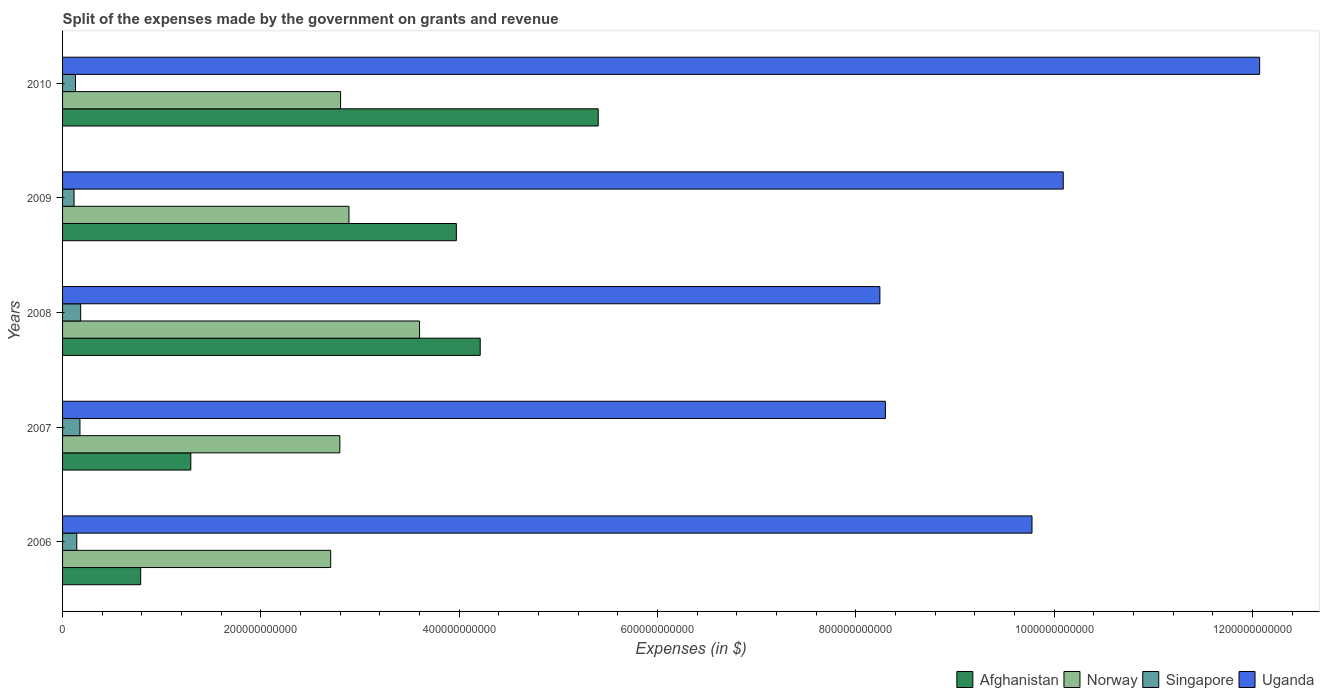How many groups of bars are there?
Offer a very short reply. 5. Are the number of bars per tick equal to the number of legend labels?
Offer a terse response. Yes. How many bars are there on the 5th tick from the top?
Your response must be concise. 4. How many bars are there on the 3rd tick from the bottom?
Offer a terse response. 4. In how many cases, is the number of bars for a given year not equal to the number of legend labels?
Your answer should be compact. 0. What is the expenses made by the government on grants and revenue in Singapore in 2008?
Your answer should be compact. 1.82e+1. Across all years, what is the maximum expenses made by the government on grants and revenue in Norway?
Offer a very short reply. 3.60e+11. Across all years, what is the minimum expenses made by the government on grants and revenue in Norway?
Keep it short and to the point. 2.70e+11. In which year was the expenses made by the government on grants and revenue in Norway minimum?
Provide a succinct answer. 2006. What is the total expenses made by the government on grants and revenue in Norway in the graph?
Provide a succinct answer. 1.48e+12. What is the difference between the expenses made by the government on grants and revenue in Singapore in 2006 and that in 2010?
Make the answer very short. 1.27e+09. What is the difference between the expenses made by the government on grants and revenue in Afghanistan in 2010 and the expenses made by the government on grants and revenue in Uganda in 2006?
Ensure brevity in your answer.  -4.37e+11. What is the average expenses made by the government on grants and revenue in Norway per year?
Offer a terse response. 2.96e+11. In the year 2009, what is the difference between the expenses made by the government on grants and revenue in Uganda and expenses made by the government on grants and revenue in Singapore?
Your answer should be very brief. 9.98e+11. In how many years, is the expenses made by the government on grants and revenue in Singapore greater than 1080000000000 $?
Offer a terse response. 0. What is the ratio of the expenses made by the government on grants and revenue in Singapore in 2006 to that in 2008?
Offer a very short reply. 0.79. Is the expenses made by the government on grants and revenue in Singapore in 2008 less than that in 2010?
Your response must be concise. No. What is the difference between the highest and the second highest expenses made by the government on grants and revenue in Afghanistan?
Offer a very short reply. 1.19e+11. What is the difference between the highest and the lowest expenses made by the government on grants and revenue in Afghanistan?
Keep it short and to the point. 4.61e+11. In how many years, is the expenses made by the government on grants and revenue in Afghanistan greater than the average expenses made by the government on grants and revenue in Afghanistan taken over all years?
Your answer should be compact. 3. Is the sum of the expenses made by the government on grants and revenue in Afghanistan in 2006 and 2007 greater than the maximum expenses made by the government on grants and revenue in Singapore across all years?
Ensure brevity in your answer.  Yes. Is it the case that in every year, the sum of the expenses made by the government on grants and revenue in Singapore and expenses made by the government on grants and revenue in Uganda is greater than the sum of expenses made by the government on grants and revenue in Norway and expenses made by the government on grants and revenue in Afghanistan?
Make the answer very short. Yes. What does the 2nd bar from the top in 2007 represents?
Ensure brevity in your answer.  Singapore. What does the 3rd bar from the bottom in 2009 represents?
Provide a succinct answer. Singapore. How many bars are there?
Give a very brief answer. 20. What is the difference between two consecutive major ticks on the X-axis?
Ensure brevity in your answer.  2.00e+11. Are the values on the major ticks of X-axis written in scientific E-notation?
Offer a terse response. No. Does the graph contain any zero values?
Offer a terse response. No. Does the graph contain grids?
Offer a very short reply. No. How are the legend labels stacked?
Provide a succinct answer. Horizontal. What is the title of the graph?
Give a very brief answer. Split of the expenses made by the government on grants and revenue. What is the label or title of the X-axis?
Your answer should be compact. Expenses (in $). What is the Expenses (in $) of Afghanistan in 2006?
Provide a short and direct response. 7.88e+1. What is the Expenses (in $) in Norway in 2006?
Provide a short and direct response. 2.70e+11. What is the Expenses (in $) of Singapore in 2006?
Give a very brief answer. 1.43e+1. What is the Expenses (in $) of Uganda in 2006?
Keep it short and to the point. 9.78e+11. What is the Expenses (in $) of Afghanistan in 2007?
Make the answer very short. 1.29e+11. What is the Expenses (in $) in Norway in 2007?
Your response must be concise. 2.80e+11. What is the Expenses (in $) of Singapore in 2007?
Make the answer very short. 1.75e+1. What is the Expenses (in $) in Uganda in 2007?
Provide a succinct answer. 8.30e+11. What is the Expenses (in $) of Afghanistan in 2008?
Make the answer very short. 4.21e+11. What is the Expenses (in $) in Norway in 2008?
Ensure brevity in your answer.  3.60e+11. What is the Expenses (in $) in Singapore in 2008?
Offer a very short reply. 1.82e+1. What is the Expenses (in $) in Uganda in 2008?
Make the answer very short. 8.24e+11. What is the Expenses (in $) of Afghanistan in 2009?
Your answer should be compact. 3.97e+11. What is the Expenses (in $) of Norway in 2009?
Your answer should be very brief. 2.89e+11. What is the Expenses (in $) in Singapore in 2009?
Provide a short and direct response. 1.16e+1. What is the Expenses (in $) in Uganda in 2009?
Make the answer very short. 1.01e+12. What is the Expenses (in $) in Afghanistan in 2010?
Your response must be concise. 5.40e+11. What is the Expenses (in $) in Norway in 2010?
Your answer should be compact. 2.80e+11. What is the Expenses (in $) in Singapore in 2010?
Provide a short and direct response. 1.31e+1. What is the Expenses (in $) in Uganda in 2010?
Offer a terse response. 1.21e+12. Across all years, what is the maximum Expenses (in $) in Afghanistan?
Ensure brevity in your answer.  5.40e+11. Across all years, what is the maximum Expenses (in $) of Norway?
Your answer should be compact. 3.60e+11. Across all years, what is the maximum Expenses (in $) in Singapore?
Provide a succinct answer. 1.82e+1. Across all years, what is the maximum Expenses (in $) of Uganda?
Your answer should be very brief. 1.21e+12. Across all years, what is the minimum Expenses (in $) of Afghanistan?
Provide a short and direct response. 7.88e+1. Across all years, what is the minimum Expenses (in $) of Norway?
Give a very brief answer. 2.70e+11. Across all years, what is the minimum Expenses (in $) of Singapore?
Give a very brief answer. 1.16e+1. Across all years, what is the minimum Expenses (in $) of Uganda?
Offer a very short reply. 8.24e+11. What is the total Expenses (in $) of Afghanistan in the graph?
Keep it short and to the point. 1.57e+12. What is the total Expenses (in $) in Norway in the graph?
Keep it short and to the point. 1.48e+12. What is the total Expenses (in $) in Singapore in the graph?
Provide a succinct answer. 7.47e+1. What is the total Expenses (in $) in Uganda in the graph?
Keep it short and to the point. 4.85e+12. What is the difference between the Expenses (in $) of Afghanistan in 2006 and that in 2007?
Offer a very short reply. -5.06e+1. What is the difference between the Expenses (in $) of Norway in 2006 and that in 2007?
Keep it short and to the point. -9.22e+09. What is the difference between the Expenses (in $) in Singapore in 2006 and that in 2007?
Offer a terse response. -3.21e+09. What is the difference between the Expenses (in $) in Uganda in 2006 and that in 2007?
Offer a very short reply. 1.48e+11. What is the difference between the Expenses (in $) of Afghanistan in 2006 and that in 2008?
Give a very brief answer. -3.42e+11. What is the difference between the Expenses (in $) of Norway in 2006 and that in 2008?
Offer a terse response. -8.96e+1. What is the difference between the Expenses (in $) in Singapore in 2006 and that in 2008?
Ensure brevity in your answer.  -3.92e+09. What is the difference between the Expenses (in $) in Uganda in 2006 and that in 2008?
Give a very brief answer. 1.53e+11. What is the difference between the Expenses (in $) of Afghanistan in 2006 and that in 2009?
Offer a terse response. -3.18e+11. What is the difference between the Expenses (in $) in Norway in 2006 and that in 2009?
Keep it short and to the point. -1.84e+1. What is the difference between the Expenses (in $) of Singapore in 2006 and that in 2009?
Offer a very short reply. 2.75e+09. What is the difference between the Expenses (in $) in Uganda in 2006 and that in 2009?
Keep it short and to the point. -3.15e+1. What is the difference between the Expenses (in $) in Afghanistan in 2006 and that in 2010?
Your answer should be very brief. -4.61e+11. What is the difference between the Expenses (in $) in Norway in 2006 and that in 2010?
Ensure brevity in your answer.  -9.97e+09. What is the difference between the Expenses (in $) in Singapore in 2006 and that in 2010?
Offer a very short reply. 1.27e+09. What is the difference between the Expenses (in $) in Uganda in 2006 and that in 2010?
Your response must be concise. -2.30e+11. What is the difference between the Expenses (in $) in Afghanistan in 2007 and that in 2008?
Your response must be concise. -2.92e+11. What is the difference between the Expenses (in $) of Norway in 2007 and that in 2008?
Your answer should be compact. -8.04e+1. What is the difference between the Expenses (in $) of Singapore in 2007 and that in 2008?
Provide a short and direct response. -7.12e+08. What is the difference between the Expenses (in $) of Uganda in 2007 and that in 2008?
Make the answer very short. 5.56e+09. What is the difference between the Expenses (in $) in Afghanistan in 2007 and that in 2009?
Keep it short and to the point. -2.68e+11. What is the difference between the Expenses (in $) in Norway in 2007 and that in 2009?
Your answer should be very brief. -9.20e+09. What is the difference between the Expenses (in $) of Singapore in 2007 and that in 2009?
Make the answer very short. 5.96e+09. What is the difference between the Expenses (in $) in Uganda in 2007 and that in 2009?
Your answer should be compact. -1.79e+11. What is the difference between the Expenses (in $) in Afghanistan in 2007 and that in 2010?
Make the answer very short. -4.11e+11. What is the difference between the Expenses (in $) in Norway in 2007 and that in 2010?
Provide a succinct answer. -7.50e+08. What is the difference between the Expenses (in $) in Singapore in 2007 and that in 2010?
Provide a succinct answer. 4.48e+09. What is the difference between the Expenses (in $) in Uganda in 2007 and that in 2010?
Offer a terse response. -3.77e+11. What is the difference between the Expenses (in $) of Afghanistan in 2008 and that in 2009?
Offer a terse response. 2.40e+1. What is the difference between the Expenses (in $) in Norway in 2008 and that in 2009?
Provide a succinct answer. 7.12e+1. What is the difference between the Expenses (in $) of Singapore in 2008 and that in 2009?
Provide a succinct answer. 6.67e+09. What is the difference between the Expenses (in $) of Uganda in 2008 and that in 2009?
Your answer should be very brief. -1.85e+11. What is the difference between the Expenses (in $) in Afghanistan in 2008 and that in 2010?
Ensure brevity in your answer.  -1.19e+11. What is the difference between the Expenses (in $) of Norway in 2008 and that in 2010?
Your answer should be compact. 7.96e+1. What is the difference between the Expenses (in $) of Singapore in 2008 and that in 2010?
Offer a very short reply. 5.19e+09. What is the difference between the Expenses (in $) of Uganda in 2008 and that in 2010?
Offer a very short reply. -3.83e+11. What is the difference between the Expenses (in $) of Afghanistan in 2009 and that in 2010?
Your response must be concise. -1.43e+11. What is the difference between the Expenses (in $) of Norway in 2009 and that in 2010?
Your answer should be very brief. 8.45e+09. What is the difference between the Expenses (in $) in Singapore in 2009 and that in 2010?
Your answer should be compact. -1.48e+09. What is the difference between the Expenses (in $) of Uganda in 2009 and that in 2010?
Your answer should be compact. -1.98e+11. What is the difference between the Expenses (in $) in Afghanistan in 2006 and the Expenses (in $) in Norway in 2007?
Give a very brief answer. -2.01e+11. What is the difference between the Expenses (in $) of Afghanistan in 2006 and the Expenses (in $) of Singapore in 2007?
Offer a terse response. 6.12e+1. What is the difference between the Expenses (in $) in Afghanistan in 2006 and the Expenses (in $) in Uganda in 2007?
Give a very brief answer. -7.51e+11. What is the difference between the Expenses (in $) in Norway in 2006 and the Expenses (in $) in Singapore in 2007?
Keep it short and to the point. 2.53e+11. What is the difference between the Expenses (in $) of Norway in 2006 and the Expenses (in $) of Uganda in 2007?
Your response must be concise. -5.59e+11. What is the difference between the Expenses (in $) in Singapore in 2006 and the Expenses (in $) in Uganda in 2007?
Your answer should be compact. -8.15e+11. What is the difference between the Expenses (in $) in Afghanistan in 2006 and the Expenses (in $) in Norway in 2008?
Your answer should be very brief. -2.81e+11. What is the difference between the Expenses (in $) in Afghanistan in 2006 and the Expenses (in $) in Singapore in 2008?
Provide a short and direct response. 6.05e+1. What is the difference between the Expenses (in $) in Afghanistan in 2006 and the Expenses (in $) in Uganda in 2008?
Keep it short and to the point. -7.45e+11. What is the difference between the Expenses (in $) of Norway in 2006 and the Expenses (in $) of Singapore in 2008?
Provide a short and direct response. 2.52e+11. What is the difference between the Expenses (in $) of Norway in 2006 and the Expenses (in $) of Uganda in 2008?
Provide a short and direct response. -5.54e+11. What is the difference between the Expenses (in $) in Singapore in 2006 and the Expenses (in $) in Uganda in 2008?
Your response must be concise. -8.10e+11. What is the difference between the Expenses (in $) of Afghanistan in 2006 and the Expenses (in $) of Norway in 2009?
Offer a very short reply. -2.10e+11. What is the difference between the Expenses (in $) in Afghanistan in 2006 and the Expenses (in $) in Singapore in 2009?
Provide a succinct answer. 6.72e+1. What is the difference between the Expenses (in $) of Afghanistan in 2006 and the Expenses (in $) of Uganda in 2009?
Your response must be concise. -9.30e+11. What is the difference between the Expenses (in $) of Norway in 2006 and the Expenses (in $) of Singapore in 2009?
Provide a succinct answer. 2.59e+11. What is the difference between the Expenses (in $) in Norway in 2006 and the Expenses (in $) in Uganda in 2009?
Your answer should be very brief. -7.39e+11. What is the difference between the Expenses (in $) of Singapore in 2006 and the Expenses (in $) of Uganda in 2009?
Ensure brevity in your answer.  -9.95e+11. What is the difference between the Expenses (in $) of Afghanistan in 2006 and the Expenses (in $) of Norway in 2010?
Provide a short and direct response. -2.02e+11. What is the difference between the Expenses (in $) of Afghanistan in 2006 and the Expenses (in $) of Singapore in 2010?
Ensure brevity in your answer.  6.57e+1. What is the difference between the Expenses (in $) of Afghanistan in 2006 and the Expenses (in $) of Uganda in 2010?
Make the answer very short. -1.13e+12. What is the difference between the Expenses (in $) in Norway in 2006 and the Expenses (in $) in Singapore in 2010?
Offer a very short reply. 2.57e+11. What is the difference between the Expenses (in $) in Norway in 2006 and the Expenses (in $) in Uganda in 2010?
Offer a terse response. -9.37e+11. What is the difference between the Expenses (in $) of Singapore in 2006 and the Expenses (in $) of Uganda in 2010?
Ensure brevity in your answer.  -1.19e+12. What is the difference between the Expenses (in $) in Afghanistan in 2007 and the Expenses (in $) in Norway in 2008?
Your answer should be very brief. -2.31e+11. What is the difference between the Expenses (in $) in Afghanistan in 2007 and the Expenses (in $) in Singapore in 2008?
Give a very brief answer. 1.11e+11. What is the difference between the Expenses (in $) of Afghanistan in 2007 and the Expenses (in $) of Uganda in 2008?
Provide a succinct answer. -6.95e+11. What is the difference between the Expenses (in $) of Norway in 2007 and the Expenses (in $) of Singapore in 2008?
Your answer should be compact. 2.61e+11. What is the difference between the Expenses (in $) in Norway in 2007 and the Expenses (in $) in Uganda in 2008?
Give a very brief answer. -5.45e+11. What is the difference between the Expenses (in $) in Singapore in 2007 and the Expenses (in $) in Uganda in 2008?
Offer a terse response. -8.07e+11. What is the difference between the Expenses (in $) of Afghanistan in 2007 and the Expenses (in $) of Norway in 2009?
Provide a succinct answer. -1.59e+11. What is the difference between the Expenses (in $) of Afghanistan in 2007 and the Expenses (in $) of Singapore in 2009?
Provide a short and direct response. 1.18e+11. What is the difference between the Expenses (in $) in Afghanistan in 2007 and the Expenses (in $) in Uganda in 2009?
Provide a short and direct response. -8.80e+11. What is the difference between the Expenses (in $) in Norway in 2007 and the Expenses (in $) in Singapore in 2009?
Provide a short and direct response. 2.68e+11. What is the difference between the Expenses (in $) of Norway in 2007 and the Expenses (in $) of Uganda in 2009?
Offer a terse response. -7.29e+11. What is the difference between the Expenses (in $) of Singapore in 2007 and the Expenses (in $) of Uganda in 2009?
Your response must be concise. -9.92e+11. What is the difference between the Expenses (in $) of Afghanistan in 2007 and the Expenses (in $) of Norway in 2010?
Make the answer very short. -1.51e+11. What is the difference between the Expenses (in $) of Afghanistan in 2007 and the Expenses (in $) of Singapore in 2010?
Your answer should be compact. 1.16e+11. What is the difference between the Expenses (in $) of Afghanistan in 2007 and the Expenses (in $) of Uganda in 2010?
Offer a terse response. -1.08e+12. What is the difference between the Expenses (in $) of Norway in 2007 and the Expenses (in $) of Singapore in 2010?
Provide a succinct answer. 2.67e+11. What is the difference between the Expenses (in $) in Norway in 2007 and the Expenses (in $) in Uganda in 2010?
Ensure brevity in your answer.  -9.28e+11. What is the difference between the Expenses (in $) in Singapore in 2007 and the Expenses (in $) in Uganda in 2010?
Make the answer very short. -1.19e+12. What is the difference between the Expenses (in $) in Afghanistan in 2008 and the Expenses (in $) in Norway in 2009?
Provide a succinct answer. 1.32e+11. What is the difference between the Expenses (in $) in Afghanistan in 2008 and the Expenses (in $) in Singapore in 2009?
Provide a short and direct response. 4.10e+11. What is the difference between the Expenses (in $) in Afghanistan in 2008 and the Expenses (in $) in Uganda in 2009?
Provide a short and direct response. -5.88e+11. What is the difference between the Expenses (in $) of Norway in 2008 and the Expenses (in $) of Singapore in 2009?
Give a very brief answer. 3.48e+11. What is the difference between the Expenses (in $) in Norway in 2008 and the Expenses (in $) in Uganda in 2009?
Provide a succinct answer. -6.49e+11. What is the difference between the Expenses (in $) of Singapore in 2008 and the Expenses (in $) of Uganda in 2009?
Give a very brief answer. -9.91e+11. What is the difference between the Expenses (in $) of Afghanistan in 2008 and the Expenses (in $) of Norway in 2010?
Give a very brief answer. 1.41e+11. What is the difference between the Expenses (in $) in Afghanistan in 2008 and the Expenses (in $) in Singapore in 2010?
Provide a short and direct response. 4.08e+11. What is the difference between the Expenses (in $) in Afghanistan in 2008 and the Expenses (in $) in Uganda in 2010?
Give a very brief answer. -7.86e+11. What is the difference between the Expenses (in $) in Norway in 2008 and the Expenses (in $) in Singapore in 2010?
Your answer should be compact. 3.47e+11. What is the difference between the Expenses (in $) of Norway in 2008 and the Expenses (in $) of Uganda in 2010?
Your response must be concise. -8.47e+11. What is the difference between the Expenses (in $) in Singapore in 2008 and the Expenses (in $) in Uganda in 2010?
Make the answer very short. -1.19e+12. What is the difference between the Expenses (in $) of Afghanistan in 2009 and the Expenses (in $) of Norway in 2010?
Your response must be concise. 1.17e+11. What is the difference between the Expenses (in $) of Afghanistan in 2009 and the Expenses (in $) of Singapore in 2010?
Your answer should be very brief. 3.84e+11. What is the difference between the Expenses (in $) of Afghanistan in 2009 and the Expenses (in $) of Uganda in 2010?
Provide a succinct answer. -8.10e+11. What is the difference between the Expenses (in $) of Norway in 2009 and the Expenses (in $) of Singapore in 2010?
Your answer should be very brief. 2.76e+11. What is the difference between the Expenses (in $) of Norway in 2009 and the Expenses (in $) of Uganda in 2010?
Make the answer very short. -9.18e+11. What is the difference between the Expenses (in $) in Singapore in 2009 and the Expenses (in $) in Uganda in 2010?
Ensure brevity in your answer.  -1.20e+12. What is the average Expenses (in $) in Afghanistan per year?
Provide a short and direct response. 3.13e+11. What is the average Expenses (in $) in Norway per year?
Offer a very short reply. 2.96e+11. What is the average Expenses (in $) of Singapore per year?
Keep it short and to the point. 1.49e+1. What is the average Expenses (in $) in Uganda per year?
Offer a very short reply. 9.70e+11. In the year 2006, what is the difference between the Expenses (in $) of Afghanistan and Expenses (in $) of Norway?
Ensure brevity in your answer.  -1.92e+11. In the year 2006, what is the difference between the Expenses (in $) of Afghanistan and Expenses (in $) of Singapore?
Offer a terse response. 6.44e+1. In the year 2006, what is the difference between the Expenses (in $) of Afghanistan and Expenses (in $) of Uganda?
Your answer should be compact. -8.99e+11. In the year 2006, what is the difference between the Expenses (in $) of Norway and Expenses (in $) of Singapore?
Ensure brevity in your answer.  2.56e+11. In the year 2006, what is the difference between the Expenses (in $) of Norway and Expenses (in $) of Uganda?
Keep it short and to the point. -7.07e+11. In the year 2006, what is the difference between the Expenses (in $) in Singapore and Expenses (in $) in Uganda?
Offer a very short reply. -9.63e+11. In the year 2007, what is the difference between the Expenses (in $) in Afghanistan and Expenses (in $) in Norway?
Provide a succinct answer. -1.50e+11. In the year 2007, what is the difference between the Expenses (in $) in Afghanistan and Expenses (in $) in Singapore?
Give a very brief answer. 1.12e+11. In the year 2007, what is the difference between the Expenses (in $) in Afghanistan and Expenses (in $) in Uganda?
Your response must be concise. -7.00e+11. In the year 2007, what is the difference between the Expenses (in $) in Norway and Expenses (in $) in Singapore?
Give a very brief answer. 2.62e+11. In the year 2007, what is the difference between the Expenses (in $) of Norway and Expenses (in $) of Uganda?
Your response must be concise. -5.50e+11. In the year 2007, what is the difference between the Expenses (in $) of Singapore and Expenses (in $) of Uganda?
Provide a short and direct response. -8.12e+11. In the year 2008, what is the difference between the Expenses (in $) of Afghanistan and Expenses (in $) of Norway?
Provide a succinct answer. 6.12e+1. In the year 2008, what is the difference between the Expenses (in $) of Afghanistan and Expenses (in $) of Singapore?
Your answer should be compact. 4.03e+11. In the year 2008, what is the difference between the Expenses (in $) in Afghanistan and Expenses (in $) in Uganda?
Your answer should be compact. -4.03e+11. In the year 2008, what is the difference between the Expenses (in $) in Norway and Expenses (in $) in Singapore?
Ensure brevity in your answer.  3.42e+11. In the year 2008, what is the difference between the Expenses (in $) of Norway and Expenses (in $) of Uganda?
Ensure brevity in your answer.  -4.64e+11. In the year 2008, what is the difference between the Expenses (in $) of Singapore and Expenses (in $) of Uganda?
Offer a very short reply. -8.06e+11. In the year 2009, what is the difference between the Expenses (in $) in Afghanistan and Expenses (in $) in Norway?
Make the answer very short. 1.08e+11. In the year 2009, what is the difference between the Expenses (in $) of Afghanistan and Expenses (in $) of Singapore?
Ensure brevity in your answer.  3.86e+11. In the year 2009, what is the difference between the Expenses (in $) of Afghanistan and Expenses (in $) of Uganda?
Provide a succinct answer. -6.12e+11. In the year 2009, what is the difference between the Expenses (in $) in Norway and Expenses (in $) in Singapore?
Give a very brief answer. 2.77e+11. In the year 2009, what is the difference between the Expenses (in $) in Norway and Expenses (in $) in Uganda?
Keep it short and to the point. -7.20e+11. In the year 2009, what is the difference between the Expenses (in $) in Singapore and Expenses (in $) in Uganda?
Offer a very short reply. -9.98e+11. In the year 2010, what is the difference between the Expenses (in $) in Afghanistan and Expenses (in $) in Norway?
Provide a short and direct response. 2.60e+11. In the year 2010, what is the difference between the Expenses (in $) in Afghanistan and Expenses (in $) in Singapore?
Make the answer very short. 5.27e+11. In the year 2010, what is the difference between the Expenses (in $) of Afghanistan and Expenses (in $) of Uganda?
Provide a short and direct response. -6.67e+11. In the year 2010, what is the difference between the Expenses (in $) of Norway and Expenses (in $) of Singapore?
Your answer should be compact. 2.67e+11. In the year 2010, what is the difference between the Expenses (in $) in Norway and Expenses (in $) in Uganda?
Make the answer very short. -9.27e+11. In the year 2010, what is the difference between the Expenses (in $) of Singapore and Expenses (in $) of Uganda?
Offer a very short reply. -1.19e+12. What is the ratio of the Expenses (in $) in Afghanistan in 2006 to that in 2007?
Offer a very short reply. 0.61. What is the ratio of the Expenses (in $) in Norway in 2006 to that in 2007?
Make the answer very short. 0.97. What is the ratio of the Expenses (in $) of Singapore in 2006 to that in 2007?
Your response must be concise. 0.82. What is the ratio of the Expenses (in $) of Uganda in 2006 to that in 2007?
Your response must be concise. 1.18. What is the ratio of the Expenses (in $) of Afghanistan in 2006 to that in 2008?
Keep it short and to the point. 0.19. What is the ratio of the Expenses (in $) in Norway in 2006 to that in 2008?
Provide a succinct answer. 0.75. What is the ratio of the Expenses (in $) in Singapore in 2006 to that in 2008?
Offer a terse response. 0.79. What is the ratio of the Expenses (in $) of Uganda in 2006 to that in 2008?
Your response must be concise. 1.19. What is the ratio of the Expenses (in $) in Afghanistan in 2006 to that in 2009?
Keep it short and to the point. 0.2. What is the ratio of the Expenses (in $) in Norway in 2006 to that in 2009?
Give a very brief answer. 0.94. What is the ratio of the Expenses (in $) of Singapore in 2006 to that in 2009?
Provide a succinct answer. 1.24. What is the ratio of the Expenses (in $) in Uganda in 2006 to that in 2009?
Your answer should be compact. 0.97. What is the ratio of the Expenses (in $) of Afghanistan in 2006 to that in 2010?
Ensure brevity in your answer.  0.15. What is the ratio of the Expenses (in $) of Norway in 2006 to that in 2010?
Offer a terse response. 0.96. What is the ratio of the Expenses (in $) in Singapore in 2006 to that in 2010?
Your answer should be very brief. 1.1. What is the ratio of the Expenses (in $) of Uganda in 2006 to that in 2010?
Make the answer very short. 0.81. What is the ratio of the Expenses (in $) in Afghanistan in 2007 to that in 2008?
Your answer should be very brief. 0.31. What is the ratio of the Expenses (in $) of Norway in 2007 to that in 2008?
Offer a terse response. 0.78. What is the ratio of the Expenses (in $) of Singapore in 2007 to that in 2008?
Offer a very short reply. 0.96. What is the ratio of the Expenses (in $) in Uganda in 2007 to that in 2008?
Your answer should be compact. 1.01. What is the ratio of the Expenses (in $) in Afghanistan in 2007 to that in 2009?
Provide a short and direct response. 0.33. What is the ratio of the Expenses (in $) in Norway in 2007 to that in 2009?
Provide a succinct answer. 0.97. What is the ratio of the Expenses (in $) of Singapore in 2007 to that in 2009?
Keep it short and to the point. 1.51. What is the ratio of the Expenses (in $) in Uganda in 2007 to that in 2009?
Give a very brief answer. 0.82. What is the ratio of the Expenses (in $) in Afghanistan in 2007 to that in 2010?
Offer a terse response. 0.24. What is the ratio of the Expenses (in $) of Singapore in 2007 to that in 2010?
Your answer should be compact. 1.34. What is the ratio of the Expenses (in $) in Uganda in 2007 to that in 2010?
Give a very brief answer. 0.69. What is the ratio of the Expenses (in $) in Afghanistan in 2008 to that in 2009?
Ensure brevity in your answer.  1.06. What is the ratio of the Expenses (in $) of Norway in 2008 to that in 2009?
Your response must be concise. 1.25. What is the ratio of the Expenses (in $) in Singapore in 2008 to that in 2009?
Give a very brief answer. 1.58. What is the ratio of the Expenses (in $) in Uganda in 2008 to that in 2009?
Your response must be concise. 0.82. What is the ratio of the Expenses (in $) of Afghanistan in 2008 to that in 2010?
Keep it short and to the point. 0.78. What is the ratio of the Expenses (in $) in Norway in 2008 to that in 2010?
Your answer should be very brief. 1.28. What is the ratio of the Expenses (in $) in Singapore in 2008 to that in 2010?
Make the answer very short. 1.4. What is the ratio of the Expenses (in $) in Uganda in 2008 to that in 2010?
Your response must be concise. 0.68. What is the ratio of the Expenses (in $) in Afghanistan in 2009 to that in 2010?
Provide a short and direct response. 0.74. What is the ratio of the Expenses (in $) in Norway in 2009 to that in 2010?
Ensure brevity in your answer.  1.03. What is the ratio of the Expenses (in $) of Singapore in 2009 to that in 2010?
Ensure brevity in your answer.  0.89. What is the ratio of the Expenses (in $) in Uganda in 2009 to that in 2010?
Your answer should be very brief. 0.84. What is the difference between the highest and the second highest Expenses (in $) of Afghanistan?
Your answer should be compact. 1.19e+11. What is the difference between the highest and the second highest Expenses (in $) in Norway?
Keep it short and to the point. 7.12e+1. What is the difference between the highest and the second highest Expenses (in $) of Singapore?
Offer a very short reply. 7.12e+08. What is the difference between the highest and the second highest Expenses (in $) in Uganda?
Provide a short and direct response. 1.98e+11. What is the difference between the highest and the lowest Expenses (in $) of Afghanistan?
Give a very brief answer. 4.61e+11. What is the difference between the highest and the lowest Expenses (in $) in Norway?
Give a very brief answer. 8.96e+1. What is the difference between the highest and the lowest Expenses (in $) of Singapore?
Provide a short and direct response. 6.67e+09. What is the difference between the highest and the lowest Expenses (in $) in Uganda?
Offer a very short reply. 3.83e+11. 